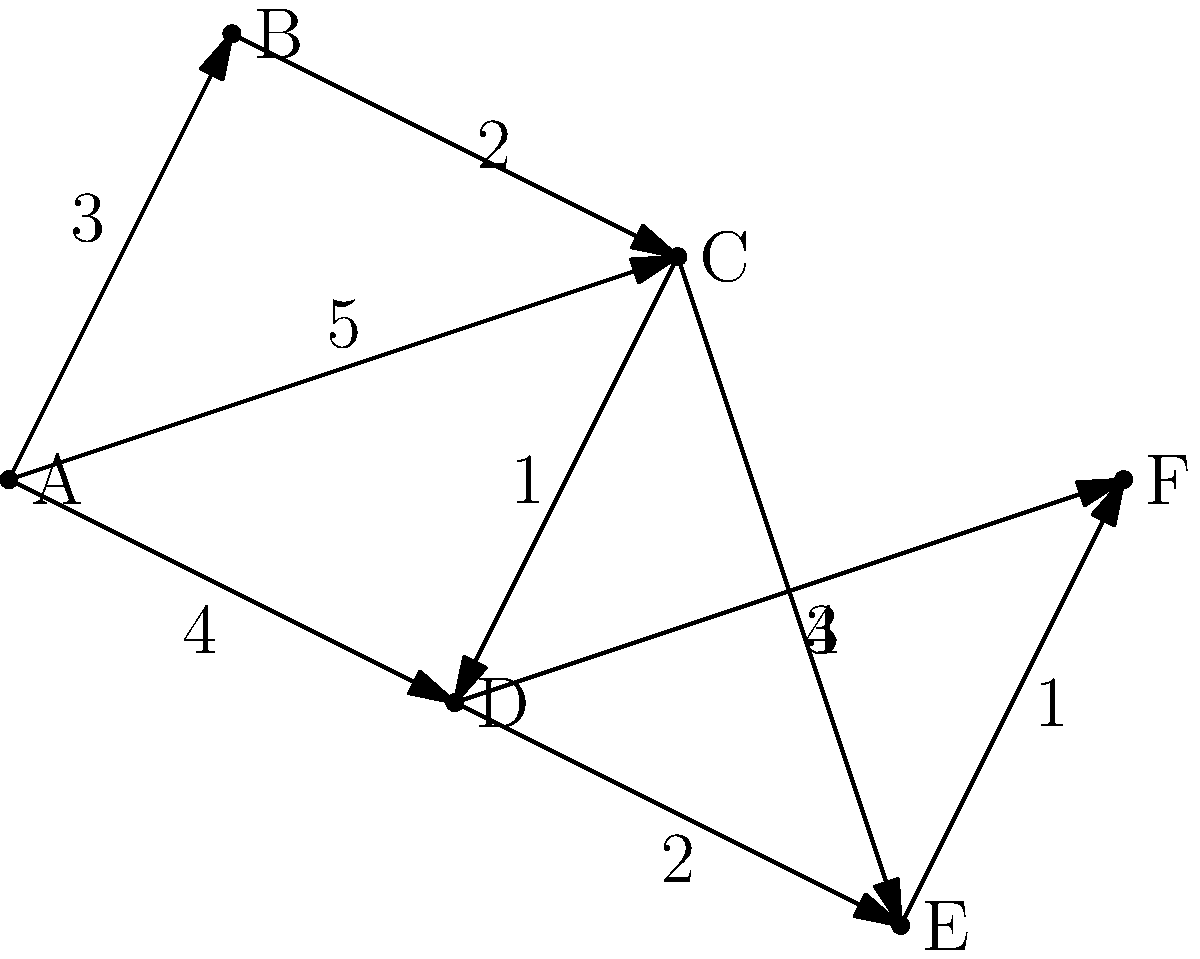As an audiophile planning a concert tour in London, you want to visit six iconic music venues represented by nodes A to F in the graph. The edges represent direct routes between venues, with weights indicating travel time in hours. What is the shortest path from venue A to venue F, and what is the total travel time? To find the shortest path from A to F, we can use Dijkstra's algorithm:

1. Initialize:
   - Distance to A = 0, all others = infinity
   - Previous node for all vertices = undefined
   - Unvisited set = {A, B, C, D, E, F}

2. From A:
   - Update: B(3), C(5), D(4)
   - Select D (shortest distance)

3. From D:
   - Update: C(5), E(6), F(8)
   - Select C (shortest distance)

4. From C:
   - Update: B(5), E(8)
   - Select B (shortest distance)

5. From B:
   - No updates
   - Select E (next shortest)

6. From E:
   - Update: F(7)
   - Select F (only remaining node)

The shortest path is A → D → C → E → F with a total distance of 7 hours.

Path breakdown:
A to D: 4 hours
D to C: 1 hour
C to E: 3 hours
E to F: 1 hour
Total: 4 + 1 + 3 + 1 = 9 hours
Answer: A → D → C → E → F, 9 hours 